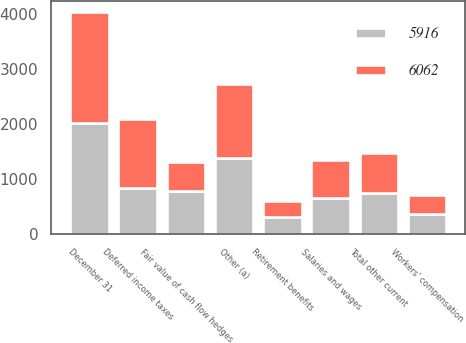Convert chart. <chart><loc_0><loc_0><loc_500><loc_500><stacked_bar_chart><ecel><fcel>December 31<fcel>Deferred income taxes<fcel>Salaries and wages<fcel>Fair value of cash flow hedges<fcel>Workers' compensation<fcel>Retirement benefits<fcel>Other (a)<fcel>Total other current<nl><fcel>6062<fcel>2016<fcel>1258<fcel>695<fcel>521<fcel>337<fcel>303<fcel>1355<fcel>737.5<nl><fcel>5916<fcel>2015<fcel>829<fcel>648<fcel>780<fcel>369<fcel>304<fcel>1376<fcel>737.5<nl></chart> 